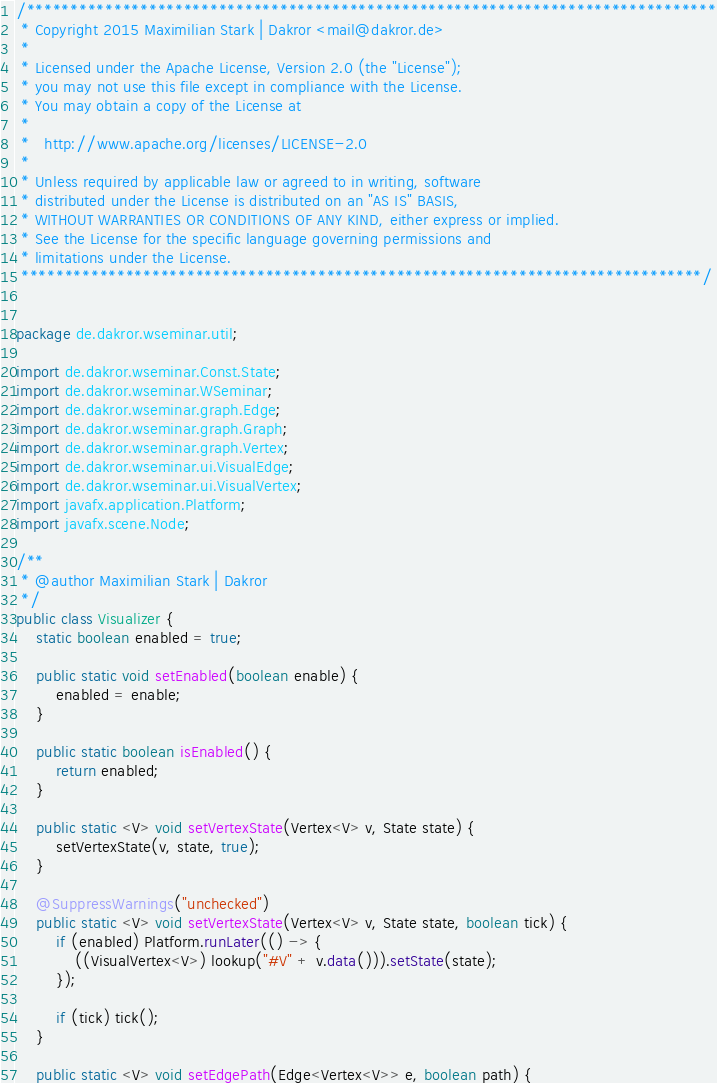Convert code to text. <code><loc_0><loc_0><loc_500><loc_500><_Java_>/*******************************************************************************
 * Copyright 2015 Maximilian Stark | Dakror <mail@dakror.de>
 * 
 * Licensed under the Apache License, Version 2.0 (the "License");
 * you may not use this file except in compliance with the License.
 * You may obtain a copy of the License at
 * 
 *   http://www.apache.org/licenses/LICENSE-2.0
 * 
 * Unless required by applicable law or agreed to in writing, software
 * distributed under the License is distributed on an "AS IS" BASIS,
 * WITHOUT WARRANTIES OR CONDITIONS OF ANY KIND, either express or implied.
 * See the License for the specific language governing permissions and
 * limitations under the License.
 ******************************************************************************/


package de.dakror.wseminar.util;

import de.dakror.wseminar.Const.State;
import de.dakror.wseminar.WSeminar;
import de.dakror.wseminar.graph.Edge;
import de.dakror.wseminar.graph.Graph;
import de.dakror.wseminar.graph.Vertex;
import de.dakror.wseminar.ui.VisualEdge;
import de.dakror.wseminar.ui.VisualVertex;
import javafx.application.Platform;
import javafx.scene.Node;

/**
 * @author Maximilian Stark | Dakror
 */
public class Visualizer {
	static boolean enabled = true;
	
	public static void setEnabled(boolean enable) {
		enabled = enable;
	}
	
	public static boolean isEnabled() {
		return enabled;
	}
	
	public static <V> void setVertexState(Vertex<V> v, State state) {
		setVertexState(v, state, true);
	}
	
	@SuppressWarnings("unchecked")
	public static <V> void setVertexState(Vertex<V> v, State state, boolean tick) {
		if (enabled) Platform.runLater(() -> {
			((VisualVertex<V>) lookup("#V" + v.data())).setState(state);
		});
		
		if (tick) tick();
	}
	
	public static <V> void setEdgePath(Edge<Vertex<V>> e, boolean path) {</code> 